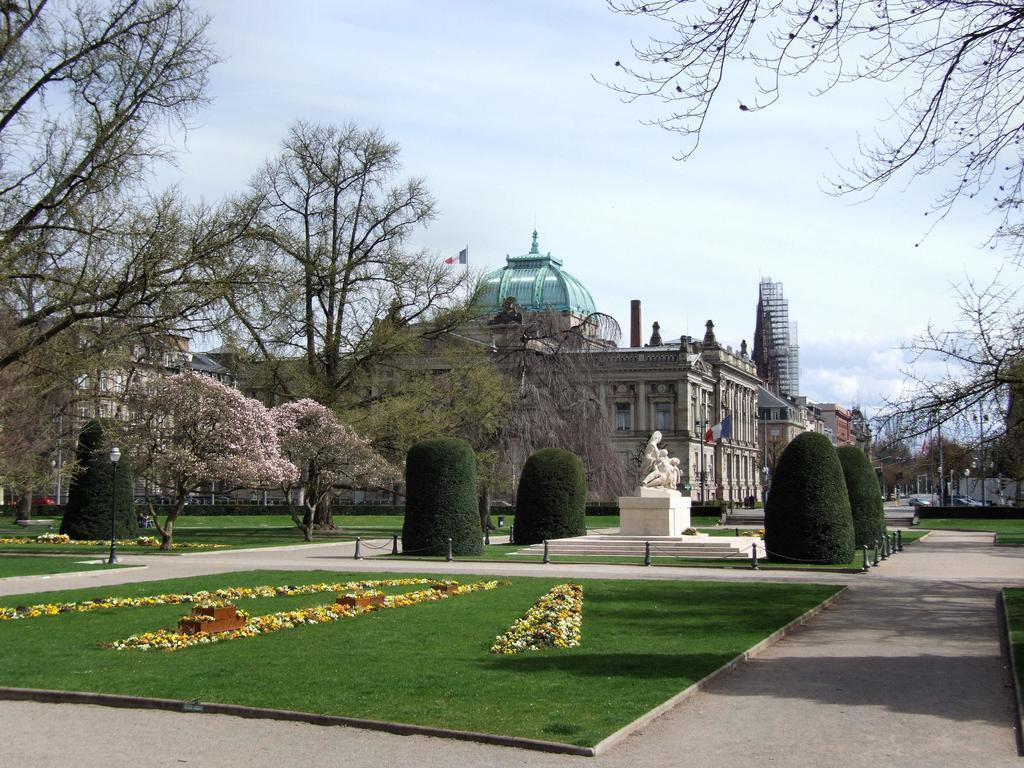What type of vegetation can be seen in the image? There is grass, flowers, and trees in the image. What kind of structure is present in the image? There is a light on a pole in the image. What is located on a platform in the image? There are statues on a platform in the image. What can be seen in the background of the image? In the background, there are buildings, lights on poles, a flag, and the sky. What type of meal is being served in the image? There is no meal present in the image; it features natural elements, structures, and background elements. 